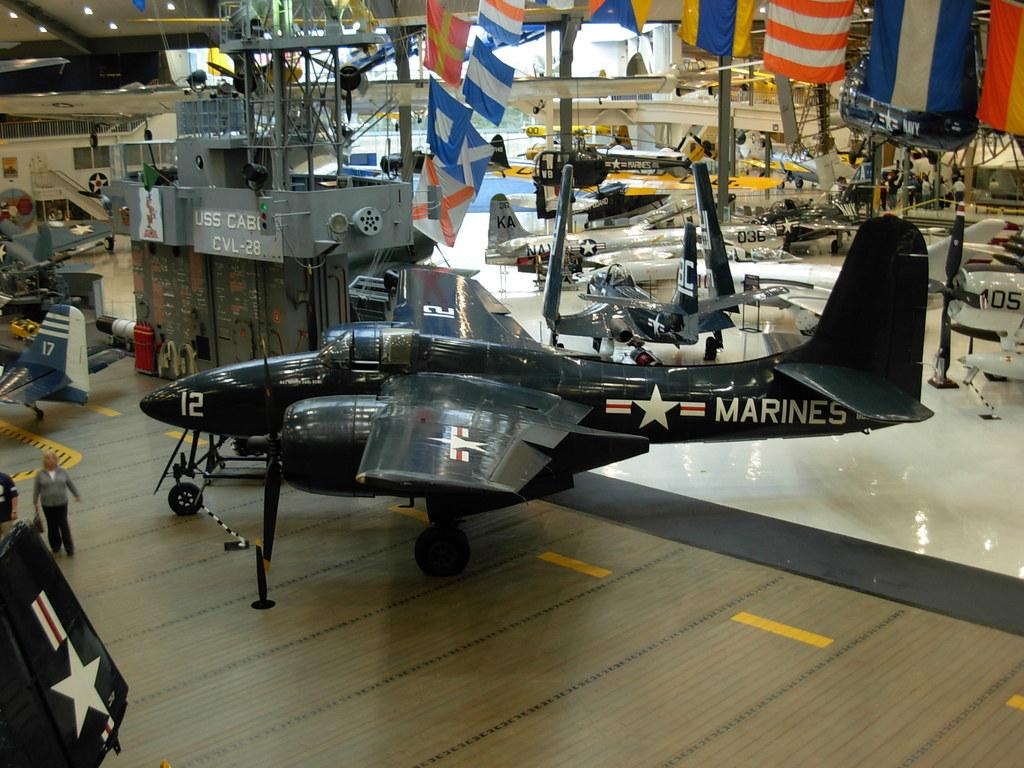<image>
Write a terse but informative summary of the picture. A person standing in front of a Marines airplane with the number twelve on the front. 